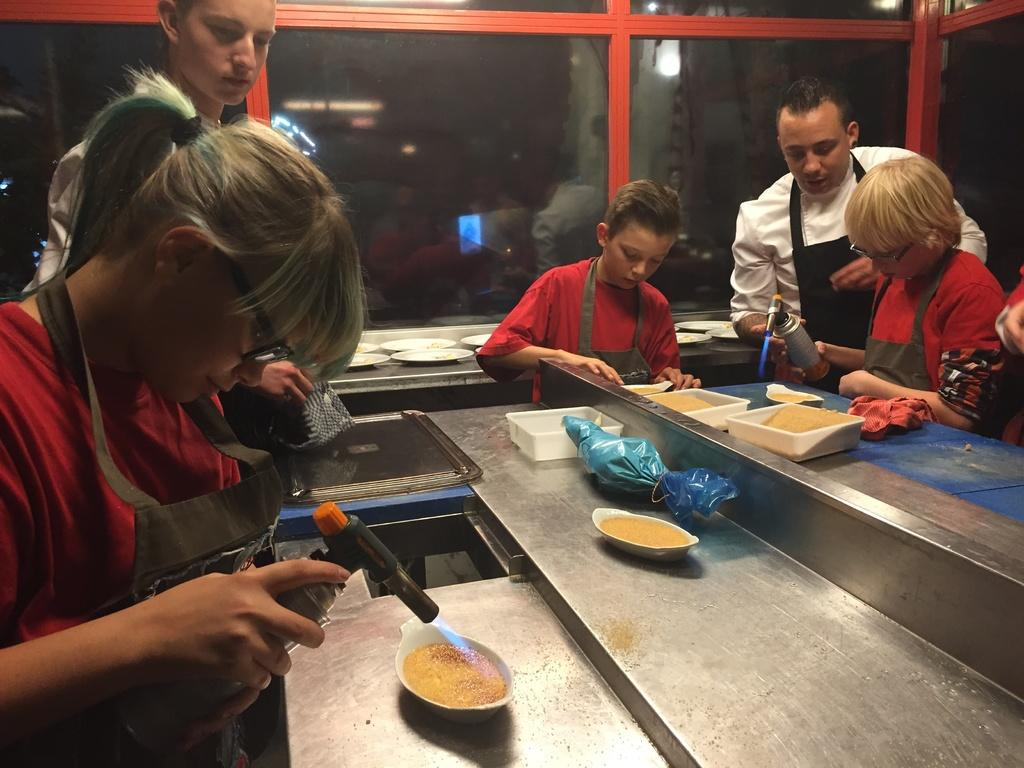How many people are in the image? There are three people in the image. Can you describe the age of the people in the image? Two of the people are children. What is present on the table in the image? There is a table, a bowl, and food on the table. What type of button is being used to control the account in the image? There is no button or account present in the image. Is there a hose visible in the image? No, there is no hose visible in the image. 